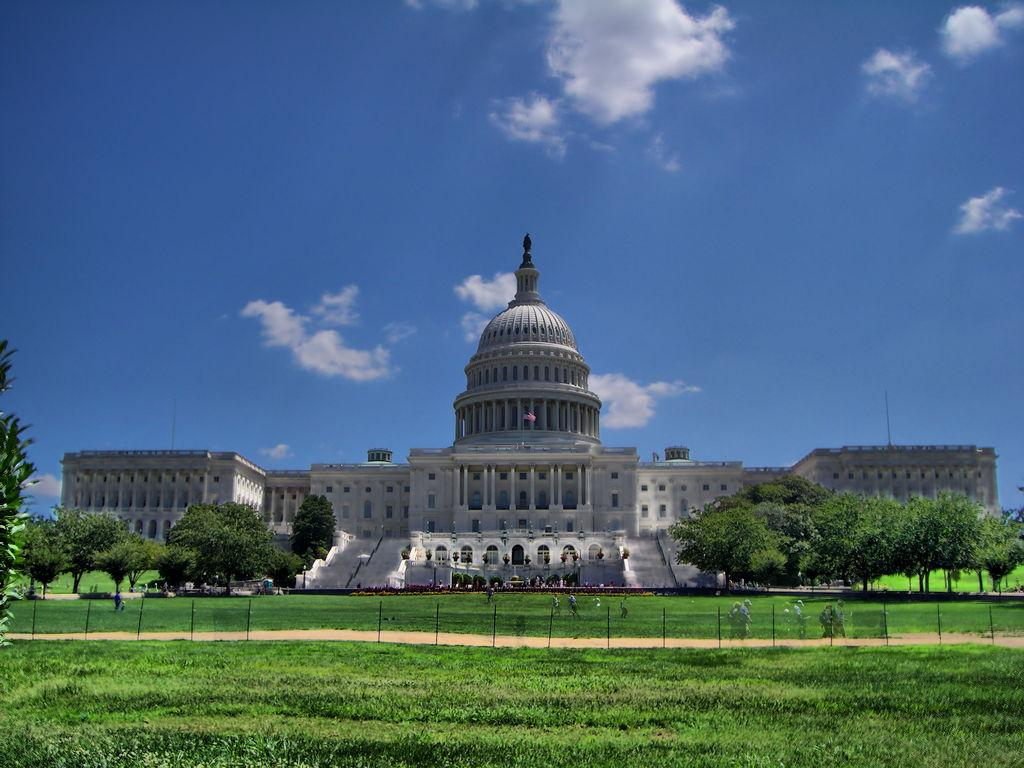What type of building is in the image? There is a bungalow in the image. What structural features can be seen on the bungalow? The bungalow has walls and pillars. What type of vegetation is present in the image? There are trees, plants, and grass in the image. What other objects can be seen in the image? There are poles in the image. What is visible in the background of the image? The sky is visible in the background of the image. Can you see any tomatoes growing on the bungalow in the image? There are no tomatoes visible in the image; it features a bungalow with trees, plants, and grass. Is there a hospital visible in the image? There is no hospital present in the image; it features a bungalow with trees, plants, and grass. 